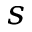<formula> <loc_0><loc_0><loc_500><loc_500>s</formula> 